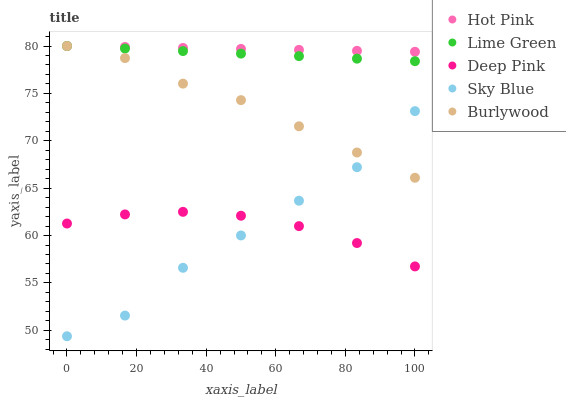Does Sky Blue have the minimum area under the curve?
Answer yes or no. Yes. Does Hot Pink have the maximum area under the curve?
Answer yes or no. Yes. Does Hot Pink have the minimum area under the curve?
Answer yes or no. No. Does Sky Blue have the maximum area under the curve?
Answer yes or no. No. Is Hot Pink the smoothest?
Answer yes or no. Yes. Is Sky Blue the roughest?
Answer yes or no. Yes. Is Sky Blue the smoothest?
Answer yes or no. No. Is Hot Pink the roughest?
Answer yes or no. No. Does Sky Blue have the lowest value?
Answer yes or no. Yes. Does Hot Pink have the lowest value?
Answer yes or no. No. Does Lime Green have the highest value?
Answer yes or no. Yes. Does Sky Blue have the highest value?
Answer yes or no. No. Is Sky Blue less than Hot Pink?
Answer yes or no. Yes. Is Burlywood greater than Deep Pink?
Answer yes or no. Yes. Does Burlywood intersect Hot Pink?
Answer yes or no. Yes. Is Burlywood less than Hot Pink?
Answer yes or no. No. Is Burlywood greater than Hot Pink?
Answer yes or no. No. Does Sky Blue intersect Hot Pink?
Answer yes or no. No. 